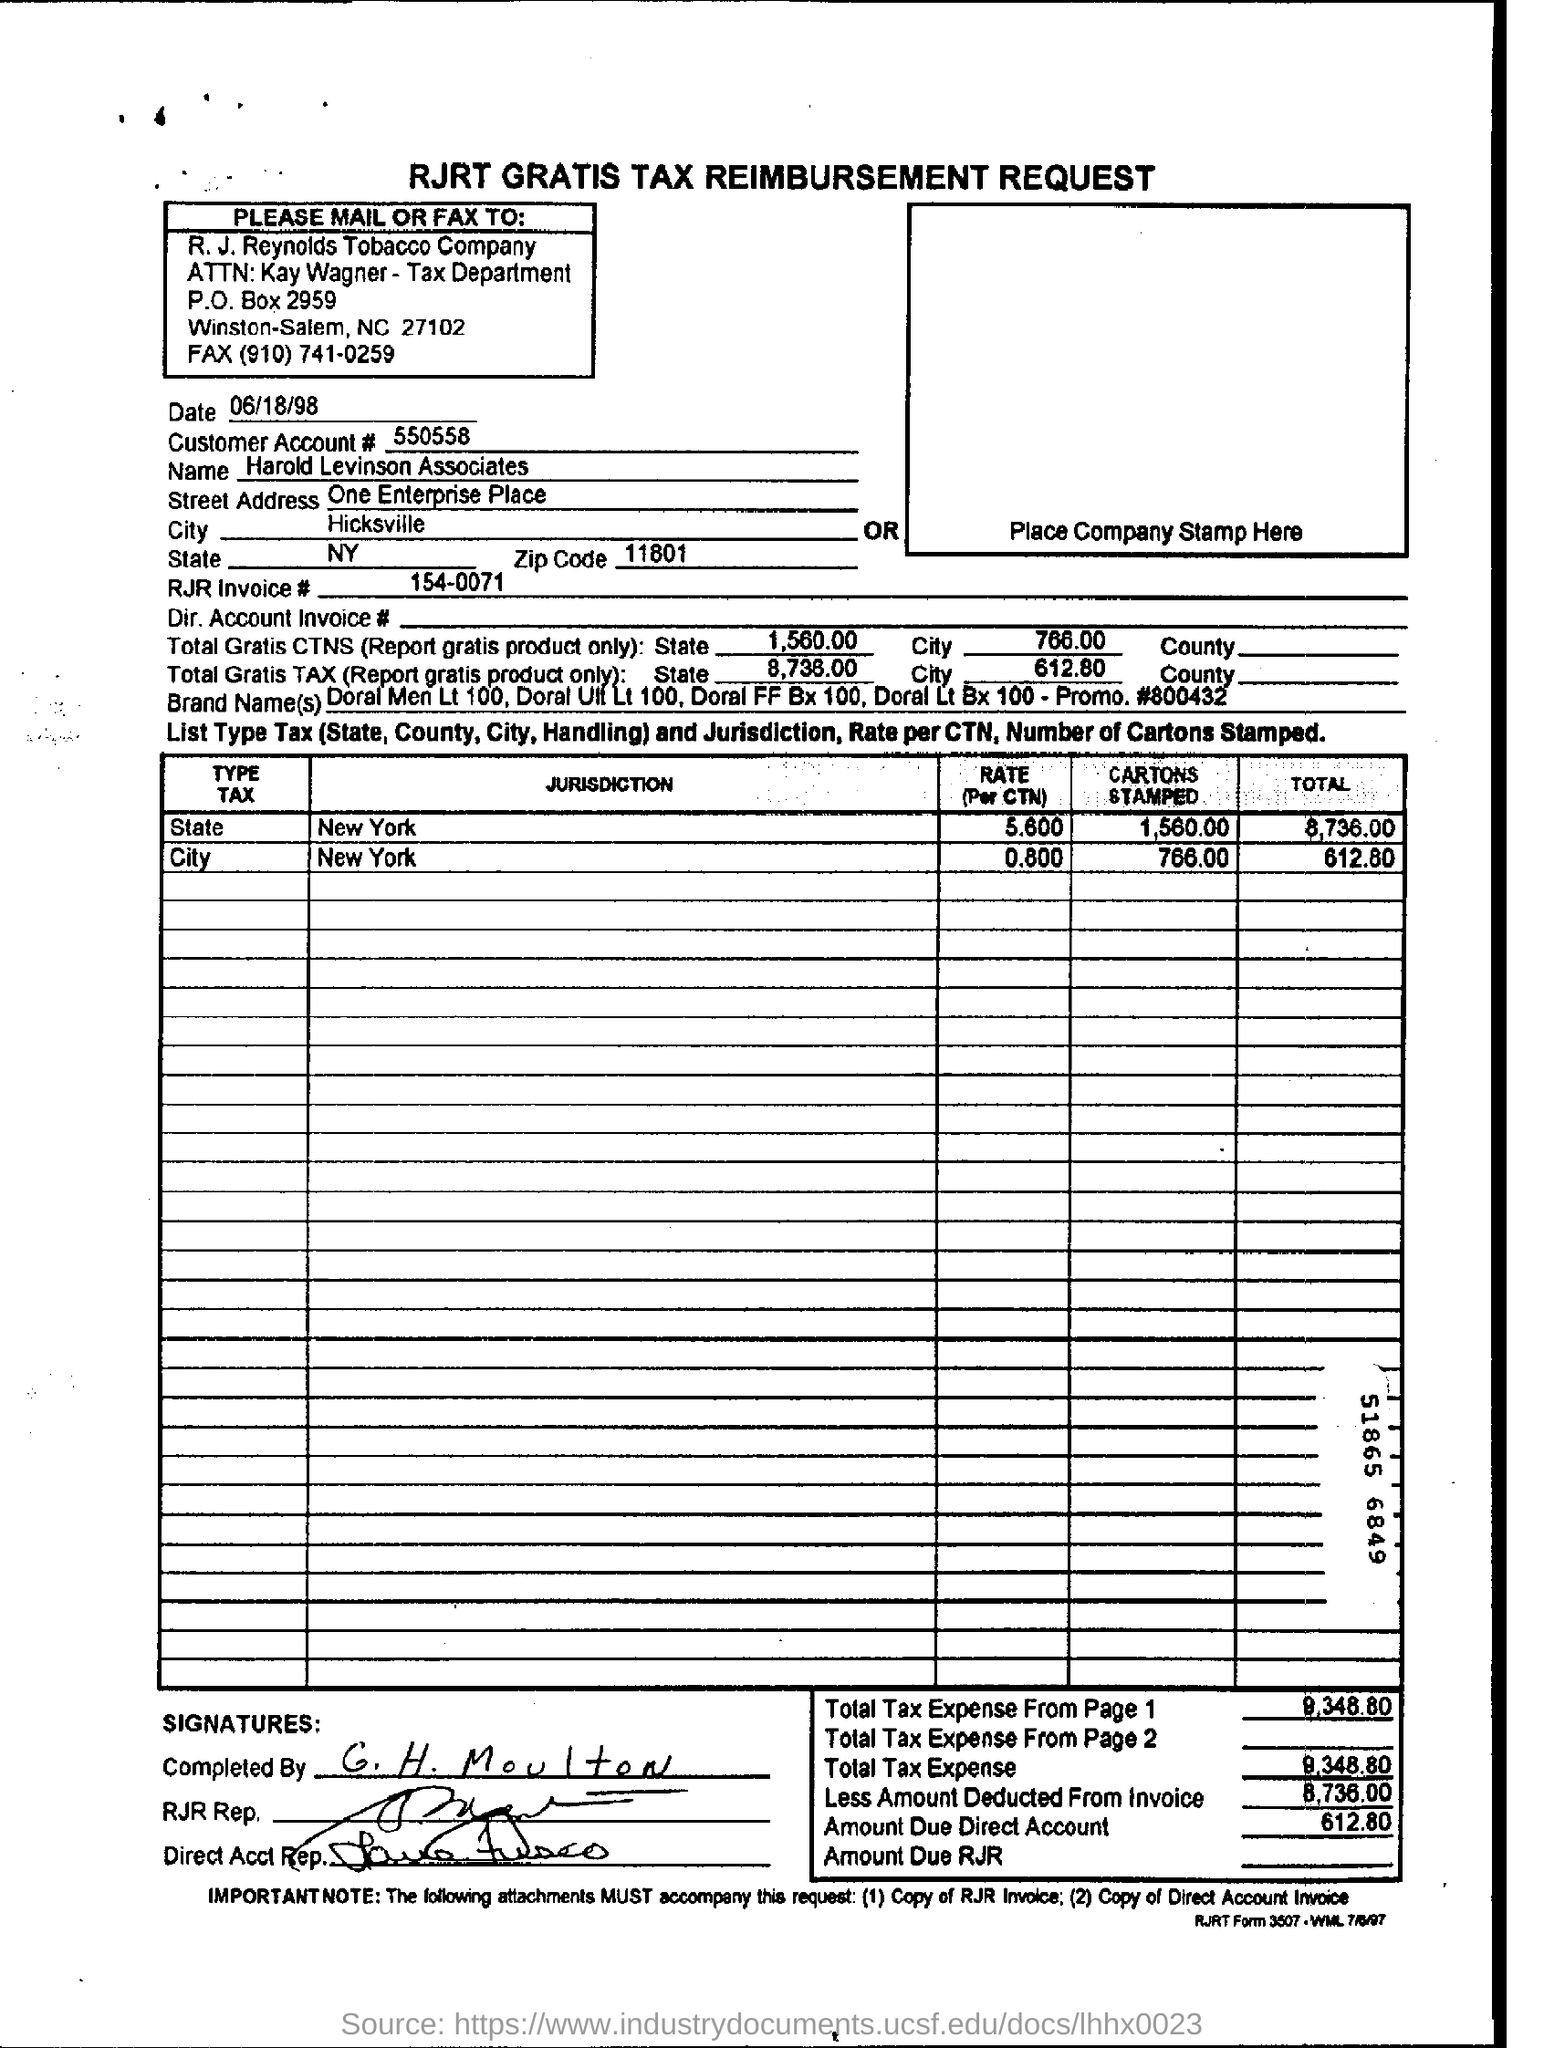What is the Document Name ?
Your answer should be very brief. RJRT GRATIS TAX REIMBURSEMENT REQUEST. What is the customer account number?
Provide a succinct answer. 550558. What is the customer name ?
Offer a very short reply. Harold Levinson Associates. How many cartons are stamped in the new york state ?
Your response must be concise. 1,560.00. What is the total Tax expense ?
Keep it short and to the point. 9348.80. What is the amount due Direct account ?
Provide a succinct answer. 612.80. Who has completed the Tax reimbursement request?
Your response must be concise. G. H. Moulton. To which company should the request be mailed to?
Offer a very short reply. R. J. Reynolds Tobacco Company. 